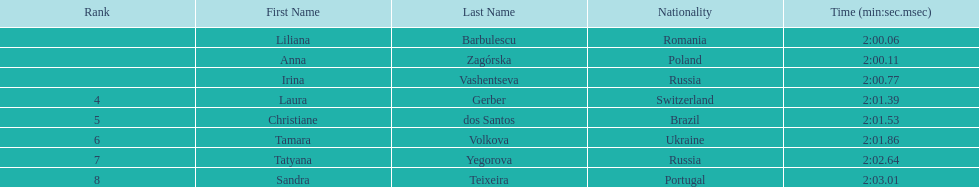In regards to anna zagorska, what was her finishing time? 2:00.11. 